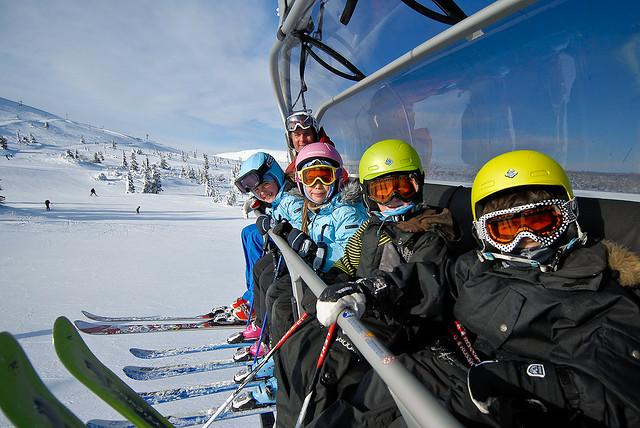Which course are the people on the lift probably being brought to?

Choices:
A) professional
B) beginner
C) advanced
D) dare devil beginner 